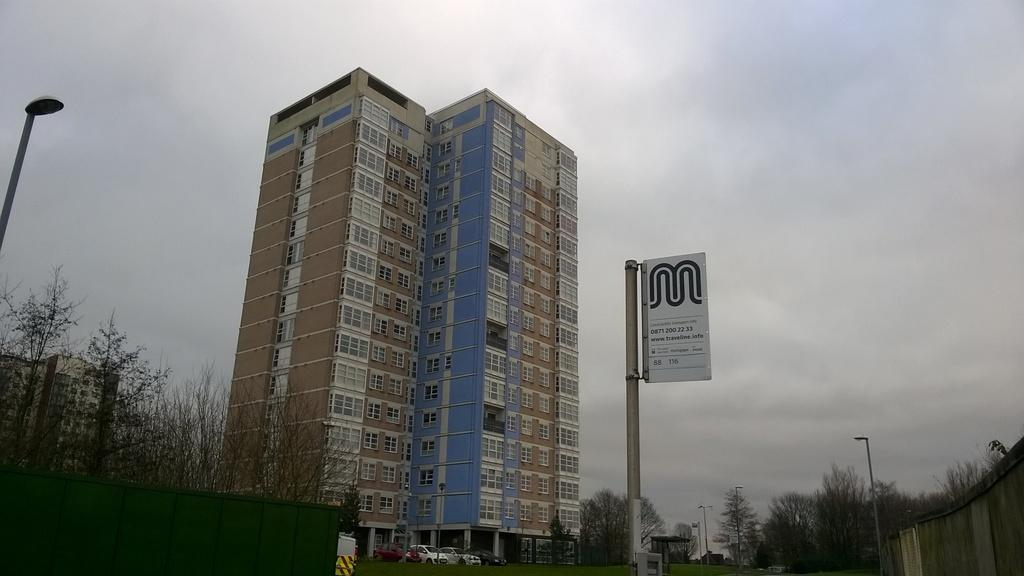What type of structures can be seen in the image? There are buildings in the image. What natural elements are present in the image? There are trees in the image. What type of lighting is present in the image? There are lamp posts in the image. What type of informational signs are present in the image? There are sign boards in the image. What type of vehicles are present in the image? There are cars in the image. What type of barrier is present in the image? There is wooden fencing in the image. Can you tell me what book the girl is reading in the image? There is no girl or book present in the image. What type of necklace is the girl wearing in the image? There is no girl or necklace present in the image. 